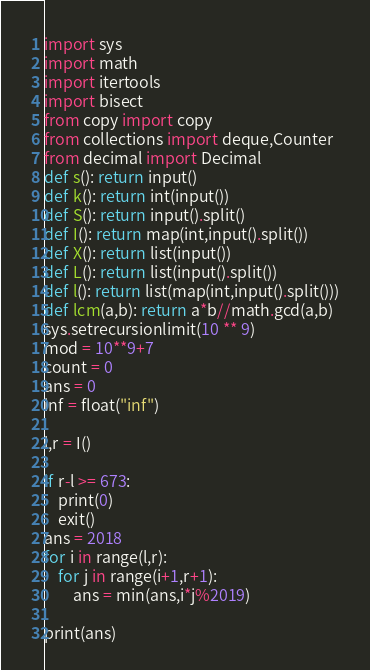<code> <loc_0><loc_0><loc_500><loc_500><_Python_>import sys
import math
import itertools
import bisect
from copy import copy
from collections import deque,Counter
from decimal import Decimal
def s(): return input()
def k(): return int(input())
def S(): return input().split()
def I(): return map(int,input().split())
def X(): return list(input())
def L(): return list(input().split())
def l(): return list(map(int,input().split()))
def lcm(a,b): return a*b//math.gcd(a,b)
sys.setrecursionlimit(10 ** 9)
mod = 10**9+7
count = 0
ans = 0
inf = float("inf")

l,r = I()

if r-l >= 673:
    print(0)
    exit()
ans = 2018
for i in range(l,r):
    for j in range(i+1,r+1):
        ans = min(ans,i*j%2019)

print(ans)
</code> 